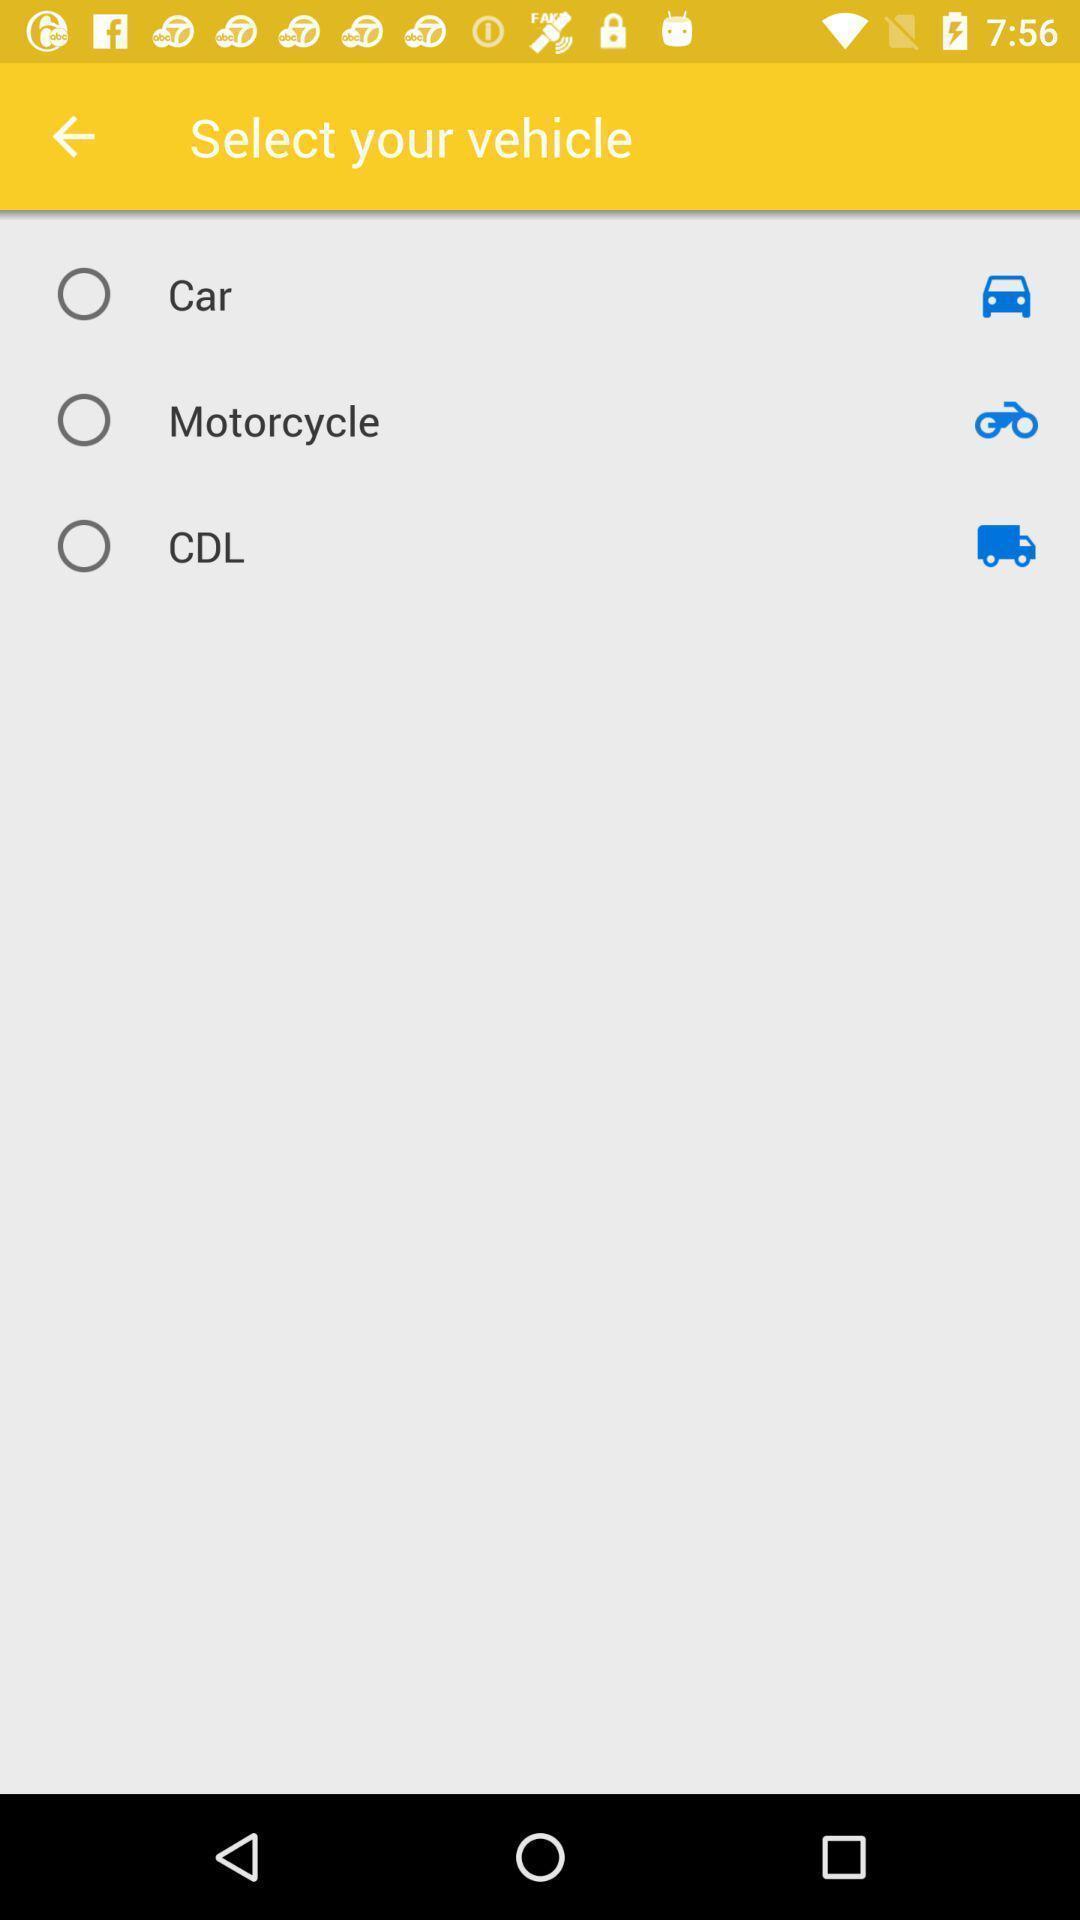Provide a detailed account of this screenshot. Page to select your vehicle. 